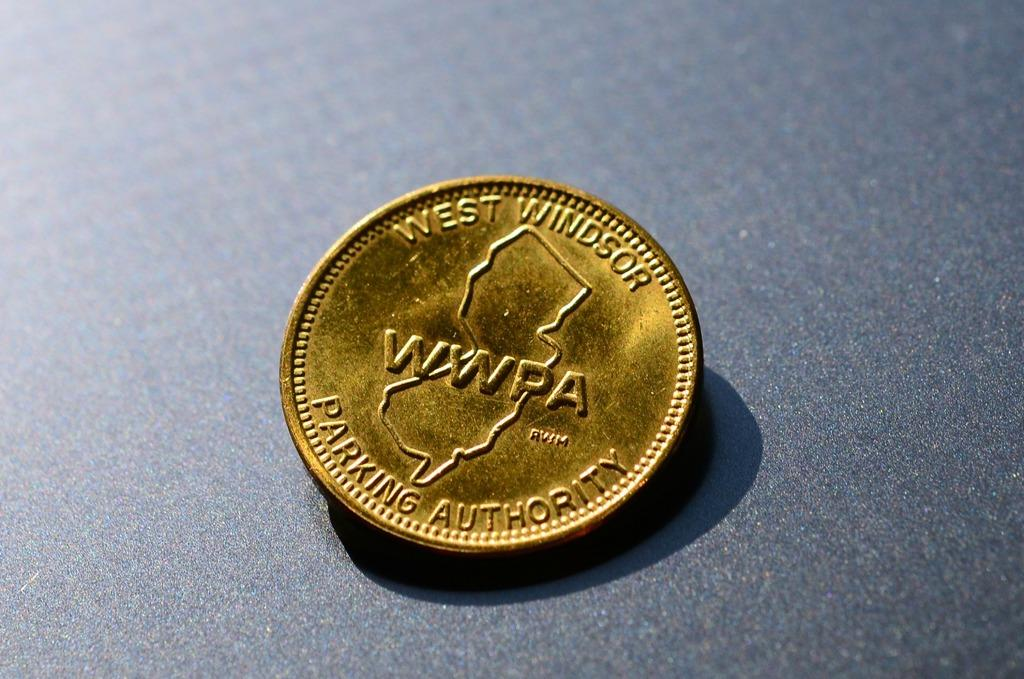<image>
Provide a brief description of the given image. The gold coin is a particular coin for parking authority. 